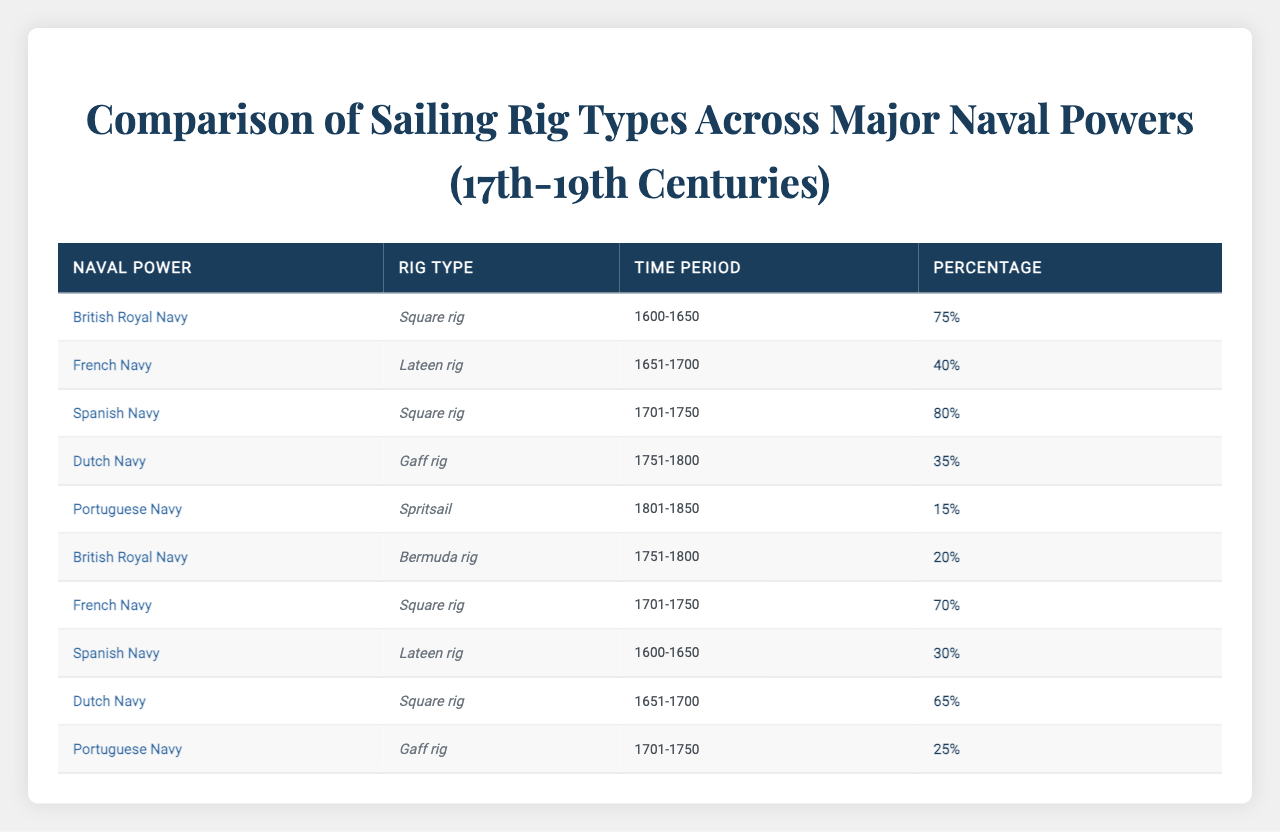What is the most common rig type used by the British Royal Navy during the period 1600-1650? The data shows that the British Royal Navy used the Square rig 75% of the time during 1600-1650, which is the highest percentage listed for this naval power in that period.
Answer: Square rig Which percentage of the Spanish Navy utilized Square rig during 1701-1750? The table indicates that the Spanish Navy used Square rig 80% of the time during the period 1701-1750.
Answer: 80% What is the total percentage of the Dutch Navy using Gaff rig and Square rig during 1751-1800? The Dutch Navy used Gaff rig 35% and no input is provided for Square rig during the same period, thus only the Gaff rig percentage applies, totaling 35%.
Answer: 35% Is it true that the French Navy used Bermuda rig during the period 1651-1700? There is no entry for the French Navy utilizing Bermuda rig during the period 1651-1700, which indicates that the statement is false.
Answer: False Which naval power had the highest percentage usage of Lateen rig in the table? Examination of the data reveals that the French Navy used Lateen rig 40% during the period 1651-1700, which is the only instance of this rig type in the dataset; therefore, it has the highest percentage among naval powers.
Answer: French Navy What is the average percentage of use for square rig across all mentioned naval powers and periods? Square rig is utilized by the British Royal Navy (75% in 1600-1650), Spanish Navy (80% in 1701-1750), and Dutch Navy (65% in 1651-1700). Adding these percentages gives (75 + 80 + 65) = 220; divided by the three entries provides an average of 73.33%.
Answer: 73.33% Which rig type was used by the Portuguese Navy during the period 1801-1850 and what was its percentage? The Portuguese Navy employed Spritsail during 1801-1850 with a usage percentage of 15%.
Answer: Spritsail, 15% What percentage did the French Navy utilize Square rig compared to the Spanish Navy's usage of Lateen rig in the periods they corresponded? The French Navy had a 70% usage of Square rig during 1701-1750, while the Spanish Navy used 30% of Lateen rig during 1600-1650. This means the French Navy's usage was actually higher by 40%.
Answer: 40% higher Was there any instance of the Dutch Navy using Bermuda rig in the recorded data? The table does not show any record indicating the Dutch Navy using Bermuda rig at any time, confirming that there are no such instances.
Answer: No 